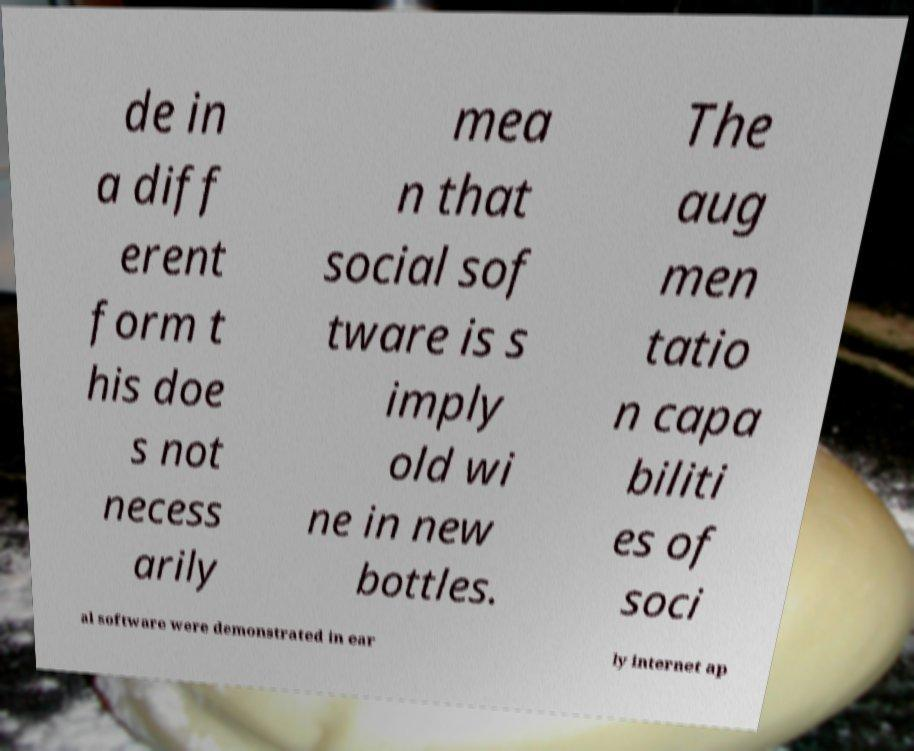Could you assist in decoding the text presented in this image and type it out clearly? de in a diff erent form t his doe s not necess arily mea n that social sof tware is s imply old wi ne in new bottles. The aug men tatio n capa biliti es of soci al software were demonstrated in ear ly internet ap 